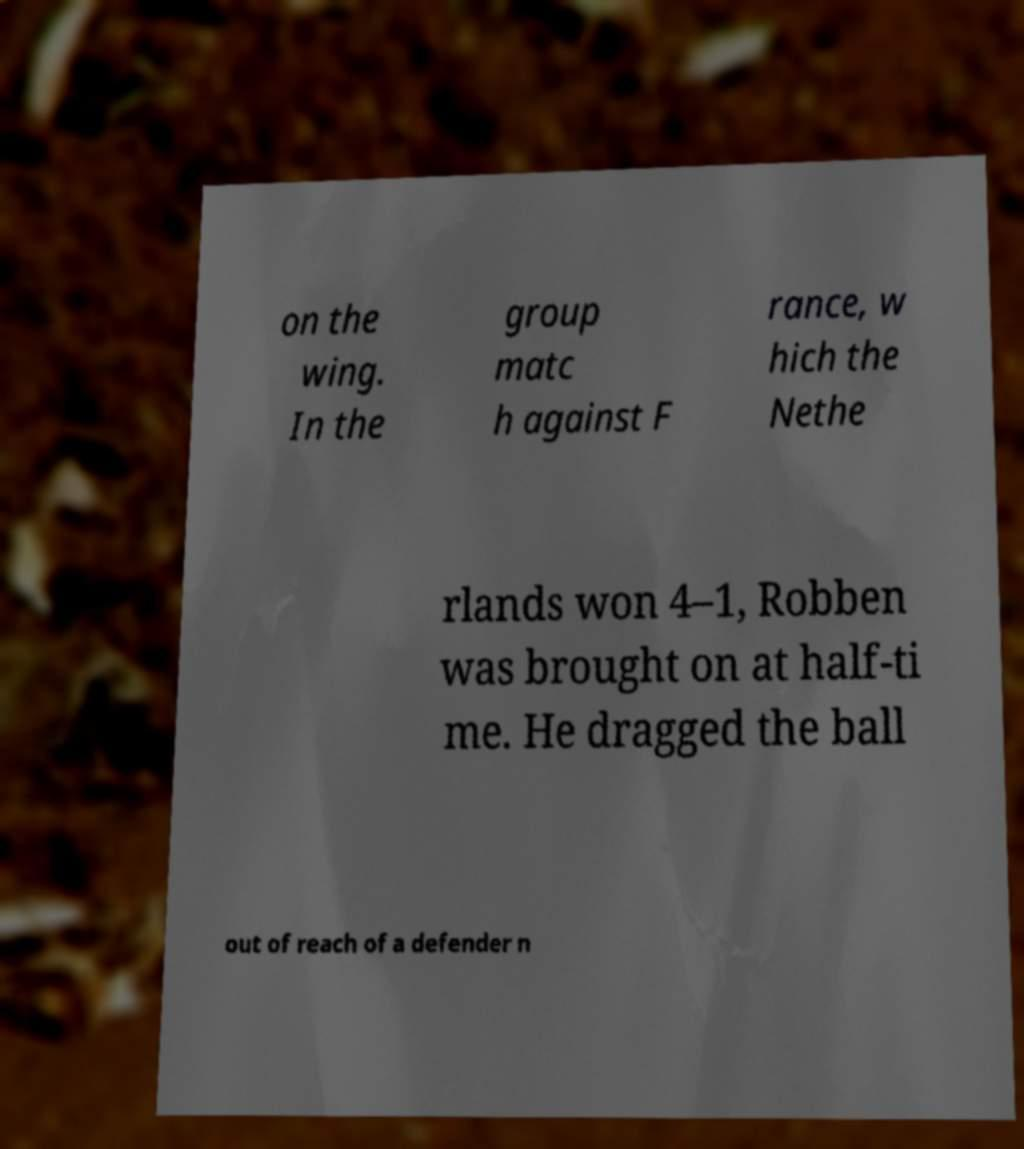Please identify and transcribe the text found in this image. on the wing. In the group matc h against F rance, w hich the Nethe rlands won 4–1, Robben was brought on at half-ti me. He dragged the ball out of reach of a defender n 